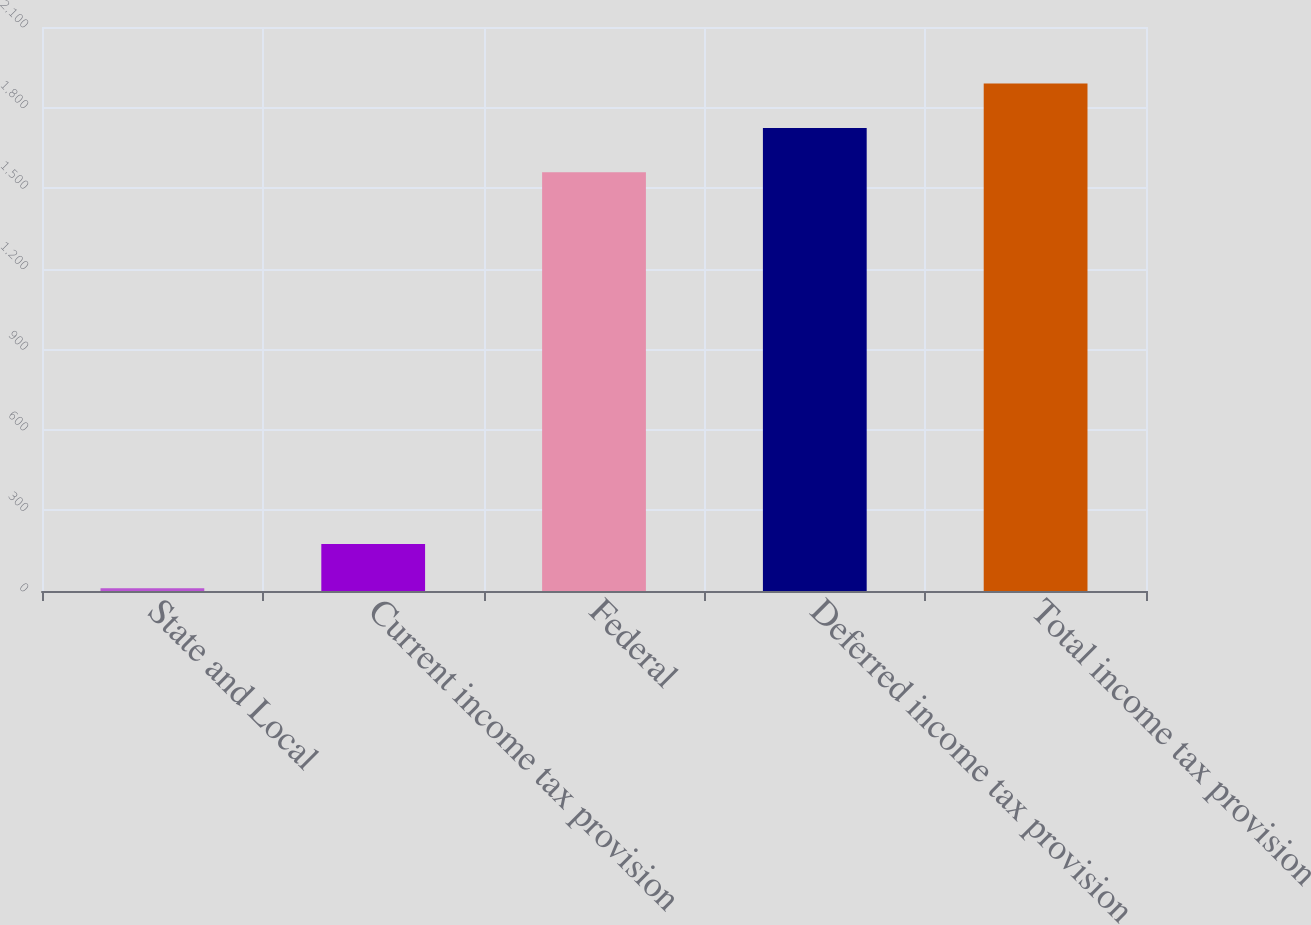Convert chart to OTSL. <chart><loc_0><loc_0><loc_500><loc_500><bar_chart><fcel>State and Local<fcel>Current income tax provision<fcel>Federal<fcel>Deferred income tax provision<fcel>Total income tax provision<nl><fcel>10<fcel>175.2<fcel>1559<fcel>1724.2<fcel>1889.4<nl></chart> 